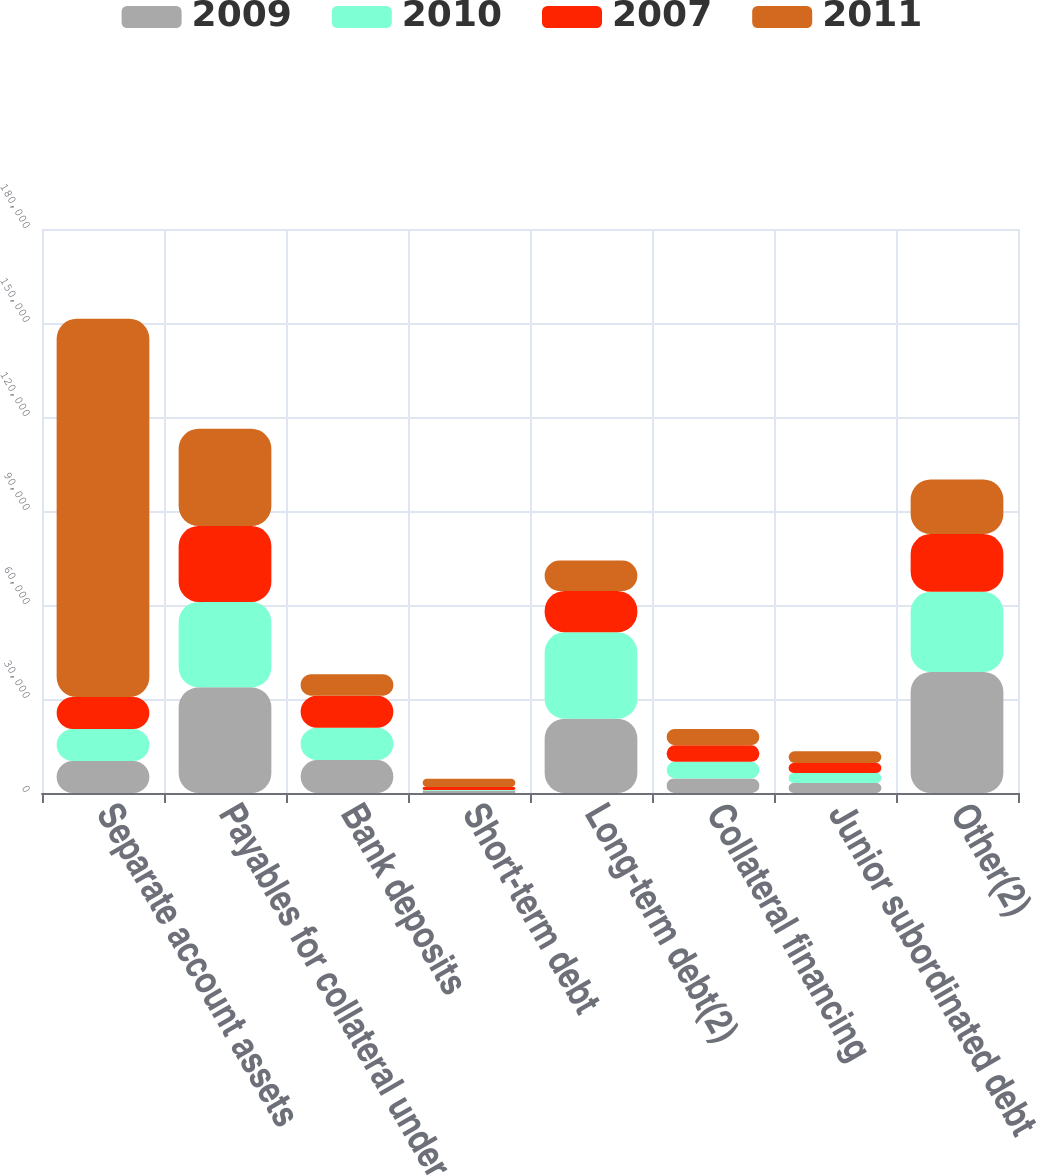<chart> <loc_0><loc_0><loc_500><loc_500><stacked_bar_chart><ecel><fcel>Separate account assets<fcel>Payables for collateral under<fcel>Bank deposits<fcel>Short-term debt<fcel>Long-term debt(2)<fcel>Collateral financing<fcel>Junior subordinated debt<fcel>Other(2)<nl><fcel>2009<fcel>10211<fcel>33716<fcel>10507<fcel>686<fcel>23692<fcel>4647<fcel>3192<fcel>38642<nl><fcel>2010<fcel>10211<fcel>27272<fcel>10316<fcel>306<fcel>27586<fcel>5297<fcel>3191<fcel>25562<nl><fcel>2007<fcel>10211<fcel>24196<fcel>10211<fcel>912<fcel>13220<fcel>5297<fcel>3191<fcel>18448<nl><fcel>2011<fcel>120697<fcel>31059<fcel>6884<fcel>2659<fcel>9667<fcel>5192<fcel>3758<fcel>17432<nl></chart> 